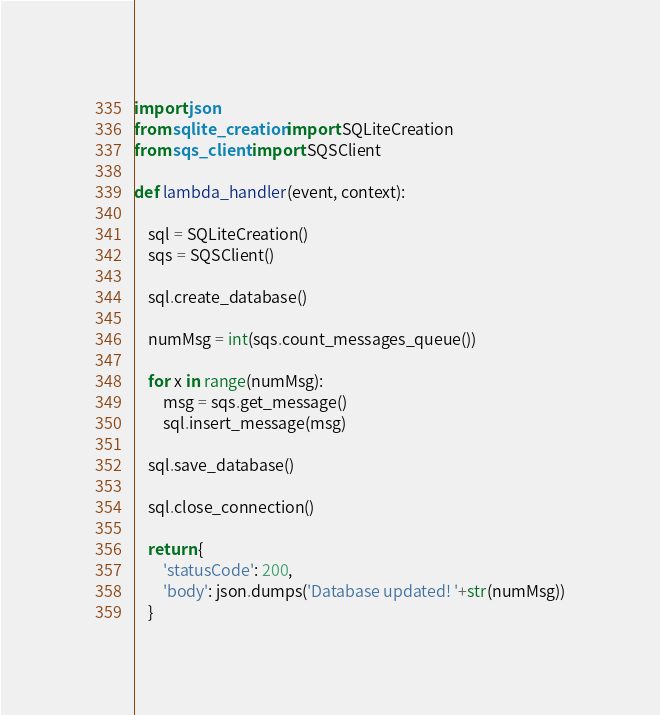<code> <loc_0><loc_0><loc_500><loc_500><_Python_>import json
from sqlite_creation import SQLiteCreation
from sqs_client import SQSClient

def lambda_handler(event, context):
    
    sql = SQLiteCreation()
    sqs = SQSClient()
    
    sql.create_database()
    
    numMsg = int(sqs.count_messages_queue())
    
    for x in range(numMsg):
        msg = sqs.get_message()
        sql.insert_message(msg)
    
    sql.save_database()
    
    sql.close_connection()
    
    return {
        'statusCode': 200,
        'body': json.dumps('Database updated! '+str(numMsg))
    }
</code> 